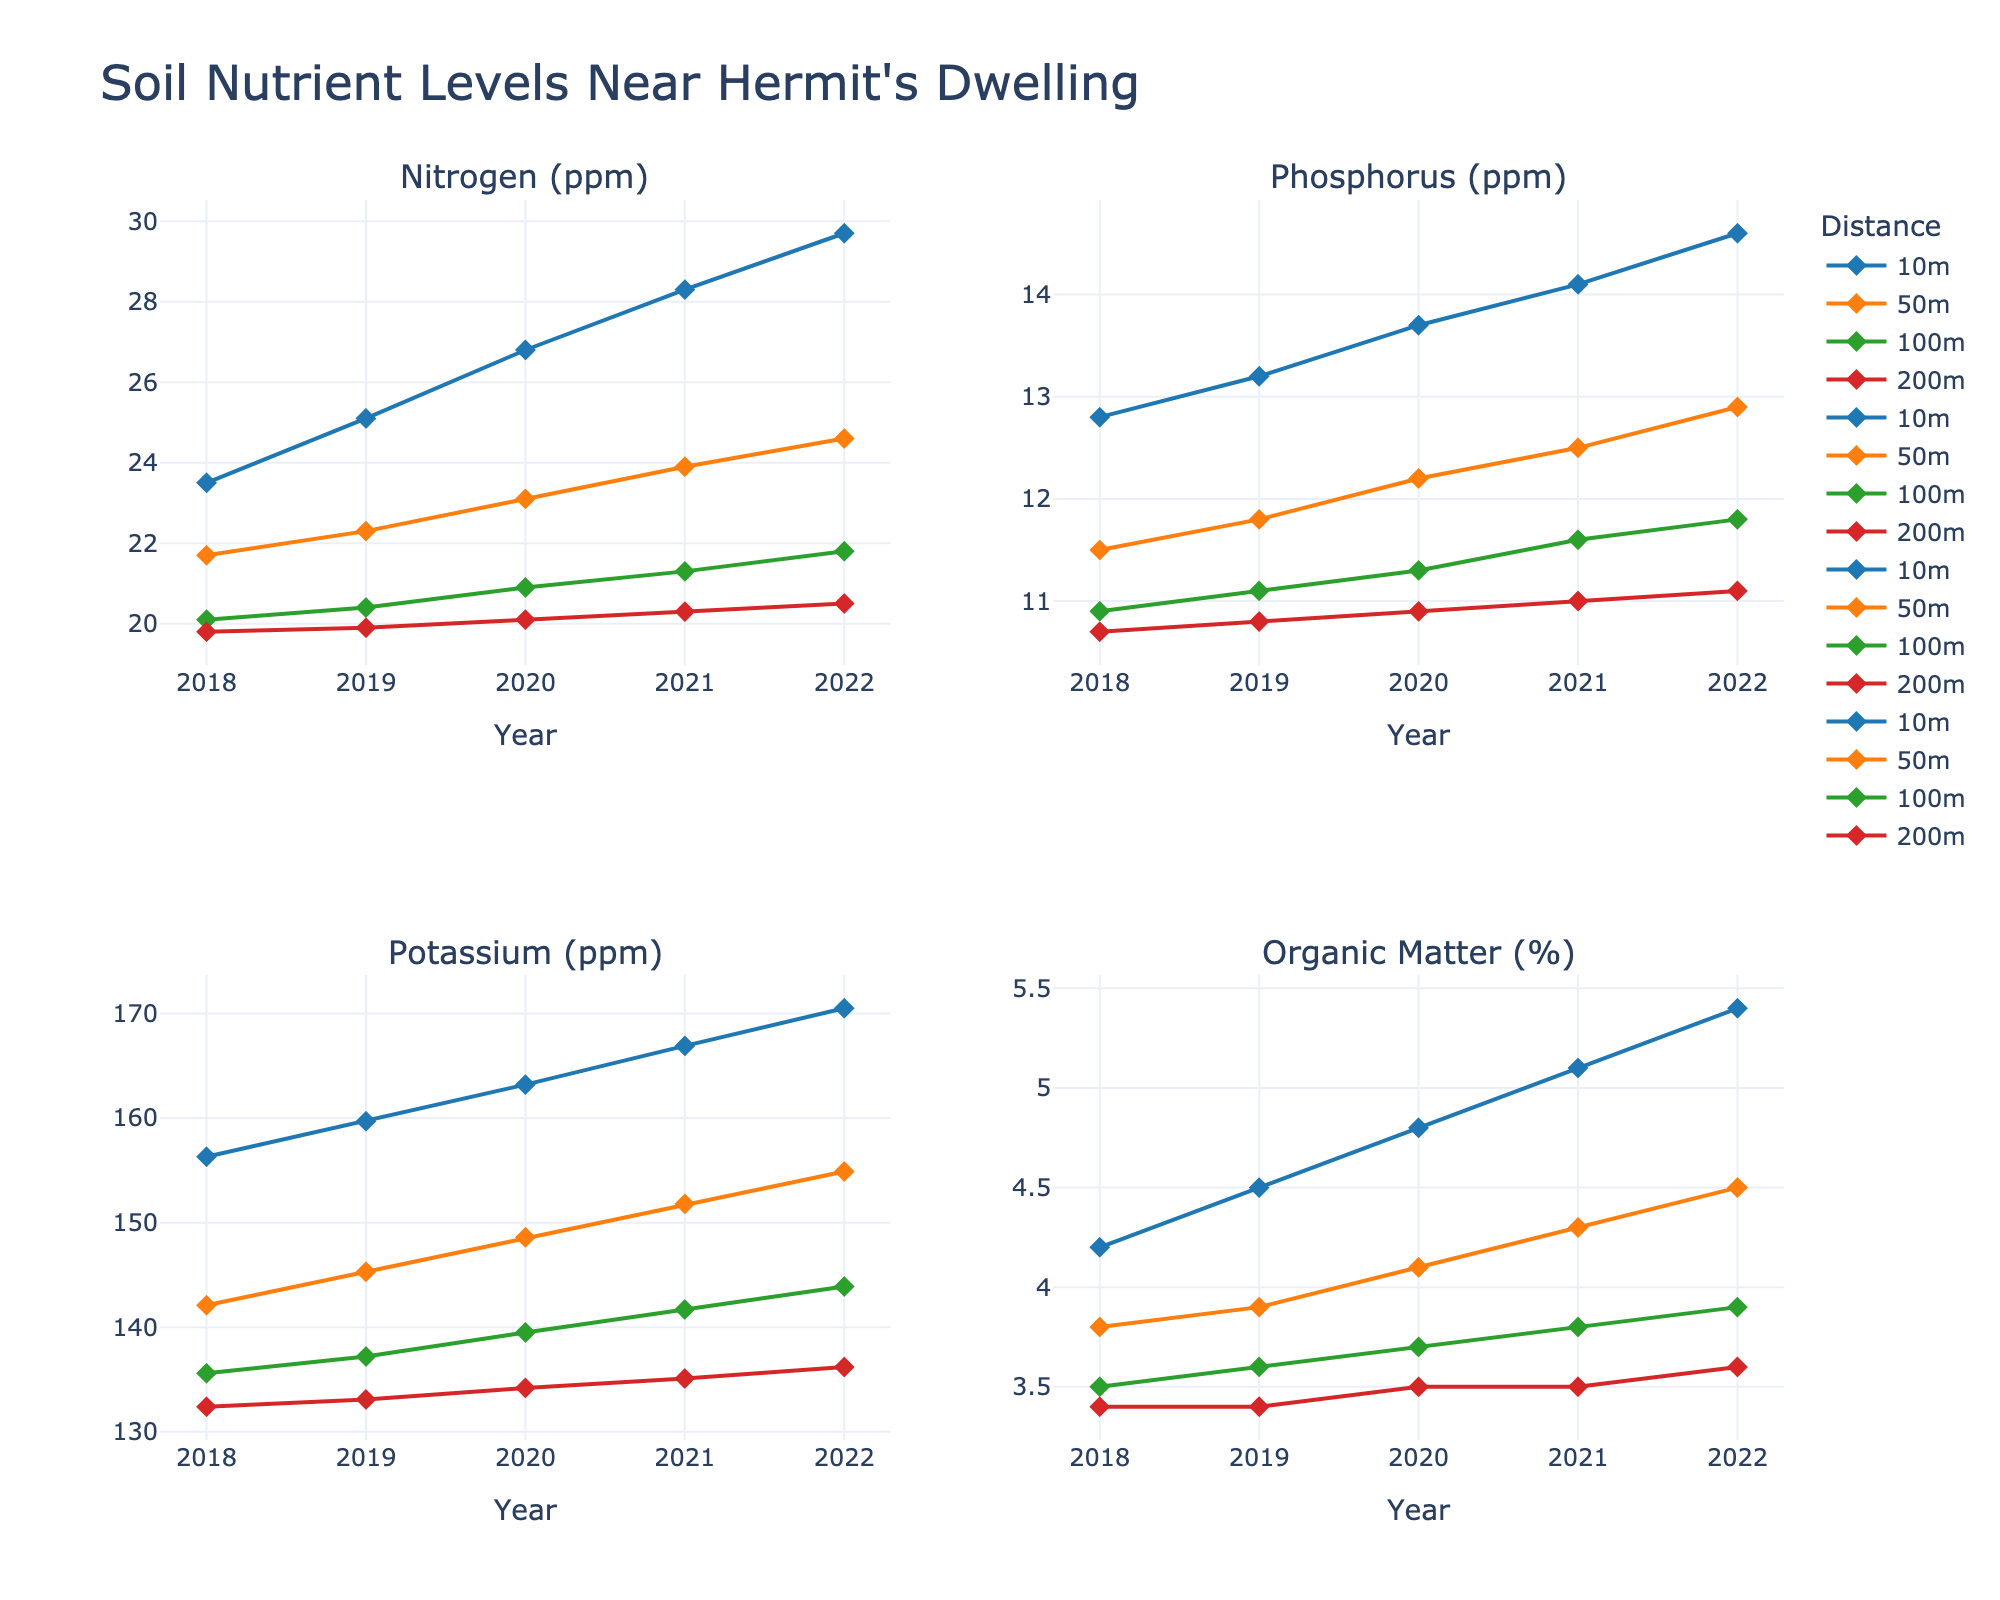What's the trend in nitrogen levels at 10 meters over the years? Look for the line representing 10 meters in the nitrogen (ppm) subplot. The nitrogen levels increase steadily from 2018 to 2022.
Answer: Increasing Which year had the highest potassium levels at 50 meters? Identify the line representing 50 meters in the potassium (ppm) subplot. The peak is observed in 2022.
Answer: 2022 How does the phosphorus level in 2021 at 100 meters compare to 200 meters? Find the phosphorus subplot for 2021 and compare the 100 meters line with the 200 meters line. The phosphorus level at 100 meters (11.6 ppm) is higher than at 200 meters (11.0 ppm).
Answer: Higher at 100 meters What's the average organic matter percentage at 10 meters from 2018 to 2022? Sum the organic matter percentages at 10 meters for each year (4.2 + 4.5 + 4.8 + 5.1 + 5.4) and divide by 5. The calculation is (24.0 / 5 = 4.8).
Answer: 4.8% Is there a significant difference in the trends of nitrogen at 50 meters and 100 meters from 2018 to 2022? Observe the nitrogen subplot lines for 50 meters and 100 meters. Both lines show an increase, but the line at 50 meters shows a smaller increment compared to 100 meters, indicating a significant difference in trends.
Answer: Yes Compare the organic matter levels in 2018 and 2022 at 200 meters. Look at the organic matter subplot for 200 meters in 2018 (3.4) and 2022 (3.6). The level slightly increased from 2018 to 2022.
Answer: Increased Which distance shows the least variation in potassium levels from 2018 to 2022? Analyze all the lines in the potassium subplot for their overall stability. The 200 meters line shows the least variation.
Answer: 200 meters What's the average phosphorus level at 100 meters in 2020 and 2021? Sum the phosphorus levels at 100 meters for 2020 and 2021 (11.3 + 11.6) and divide by 2. The calculation is (22.9 / 2 = 11.45).
Answer: 11.45 ppm How do nitrogen levels at 200 meters in 2018 compare to 2022? Compare the nitrogen levels in the nitrogen subplot for 200 meters in 2018 (19.8 ppm) and 2022 (20.5 ppm). The nitrogen level increased.
Answer: Increased 